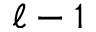<formula> <loc_0><loc_0><loc_500><loc_500>\ell - 1</formula> 